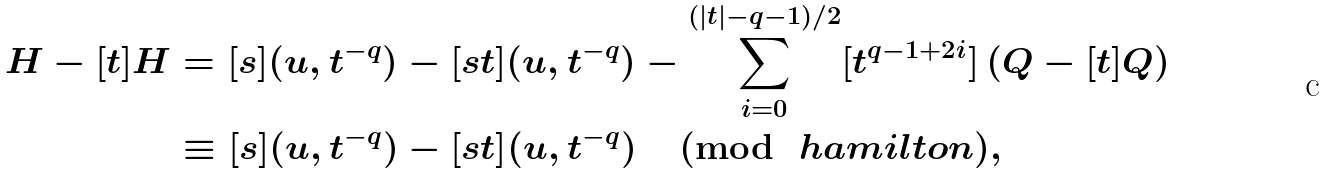Convert formula to latex. <formula><loc_0><loc_0><loc_500><loc_500>H - [ t ] H & = [ s ] ( u , t ^ { - q } ) - [ s t ] ( u , t ^ { - q } ) - \sum _ { i = 0 } ^ { ( | t | - q - 1 ) / 2 } [ t ^ { q - 1 + 2 i } ] \left ( Q - [ t ] Q \right ) \\ & \equiv [ s ] ( u , t ^ { - q } ) - [ s t ] ( u , t ^ { - q } ) \pmod { \ h a m i l t o n } ,</formula> 